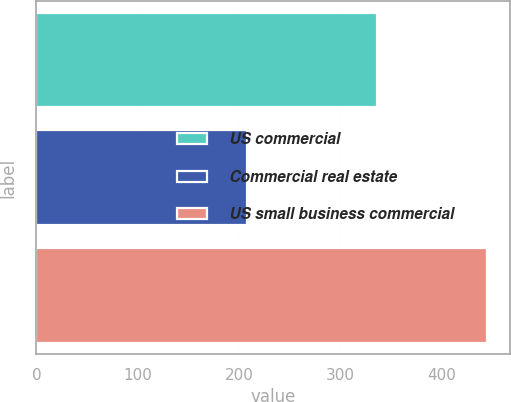Convert chart. <chart><loc_0><loc_0><loc_500><loc_500><bar_chart><fcel>US commercial<fcel>Commercial real estate<fcel>US small business commercial<nl><fcel>336<fcel>208<fcel>445<nl></chart> 